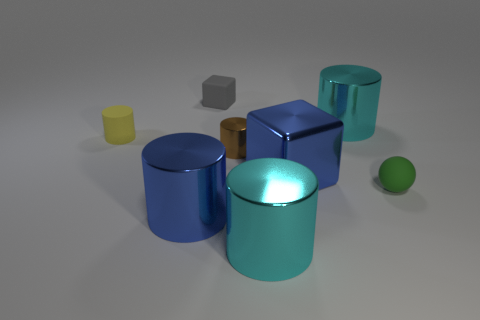The thing that is the same color as the big metallic block is what shape?
Provide a short and direct response. Cylinder. What number of tiny objects are cyan matte cylinders or brown things?
Make the answer very short. 1. There is a matte object in front of the yellow matte cylinder; does it have the same shape as the gray object?
Your answer should be very brief. No. What is the color of the small metal object that is the same shape as the yellow rubber object?
Your answer should be compact. Brown. Are there any other things that are the same shape as the tiny brown object?
Make the answer very short. Yes. Is the number of tiny cylinders that are in front of the yellow matte cylinder the same as the number of small rubber objects?
Your response must be concise. No. How many metal cylinders are both on the right side of the small gray thing and in front of the small yellow cylinder?
Provide a succinct answer. 2. What size is the other thing that is the same shape as the gray rubber object?
Make the answer very short. Large. How many cubes are made of the same material as the tiny brown cylinder?
Ensure brevity in your answer.  1. Is the number of blue cubes behind the tiny rubber block less than the number of small green matte objects?
Your answer should be compact. Yes. 